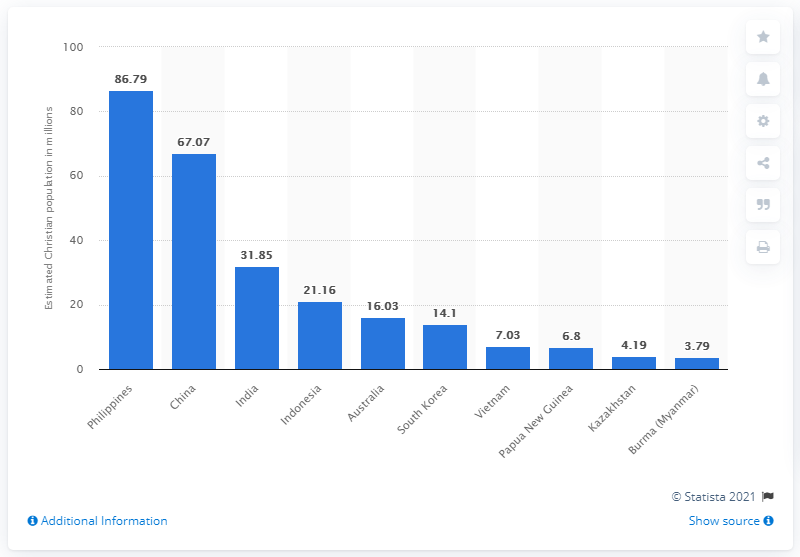Mention a couple of crucial points in this snapshot. In 2010, it is estimated that 67.07% of the population in China identified as Christian. 